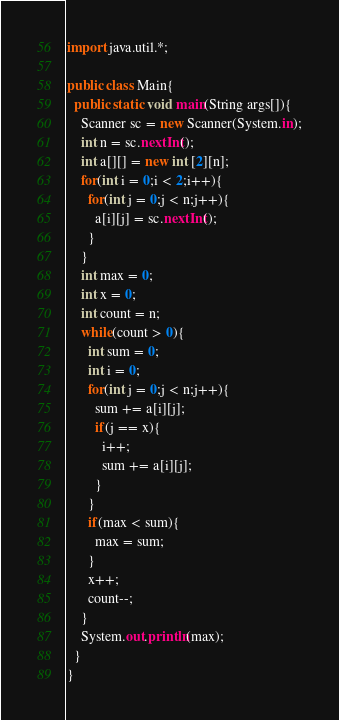<code> <loc_0><loc_0><loc_500><loc_500><_Java_>import java.util.*;

public class Main{
  public static void main(String args[]){
    Scanner sc = new Scanner(System.in);
    int n = sc.nextInt();
    int a[][] = new int [2][n];
    for(int i = 0;i < 2;i++){
      for(int j = 0;j < n;j++){
        a[i][j] = sc.nextInt();
      }
    }
    int max = 0;
    int x = 0;
    int count = n;
    while(count > 0){
      int sum = 0;
      int i = 0;
      for(int j = 0;j < n;j++){
        sum += a[i][j];
        if(j == x){
          i++;
          sum += a[i][j];
        }
      }
      if(max < sum){
        max = sum;
      }
      x++;
      count--;
    }
    System.out.println(max);
  }
}</code> 